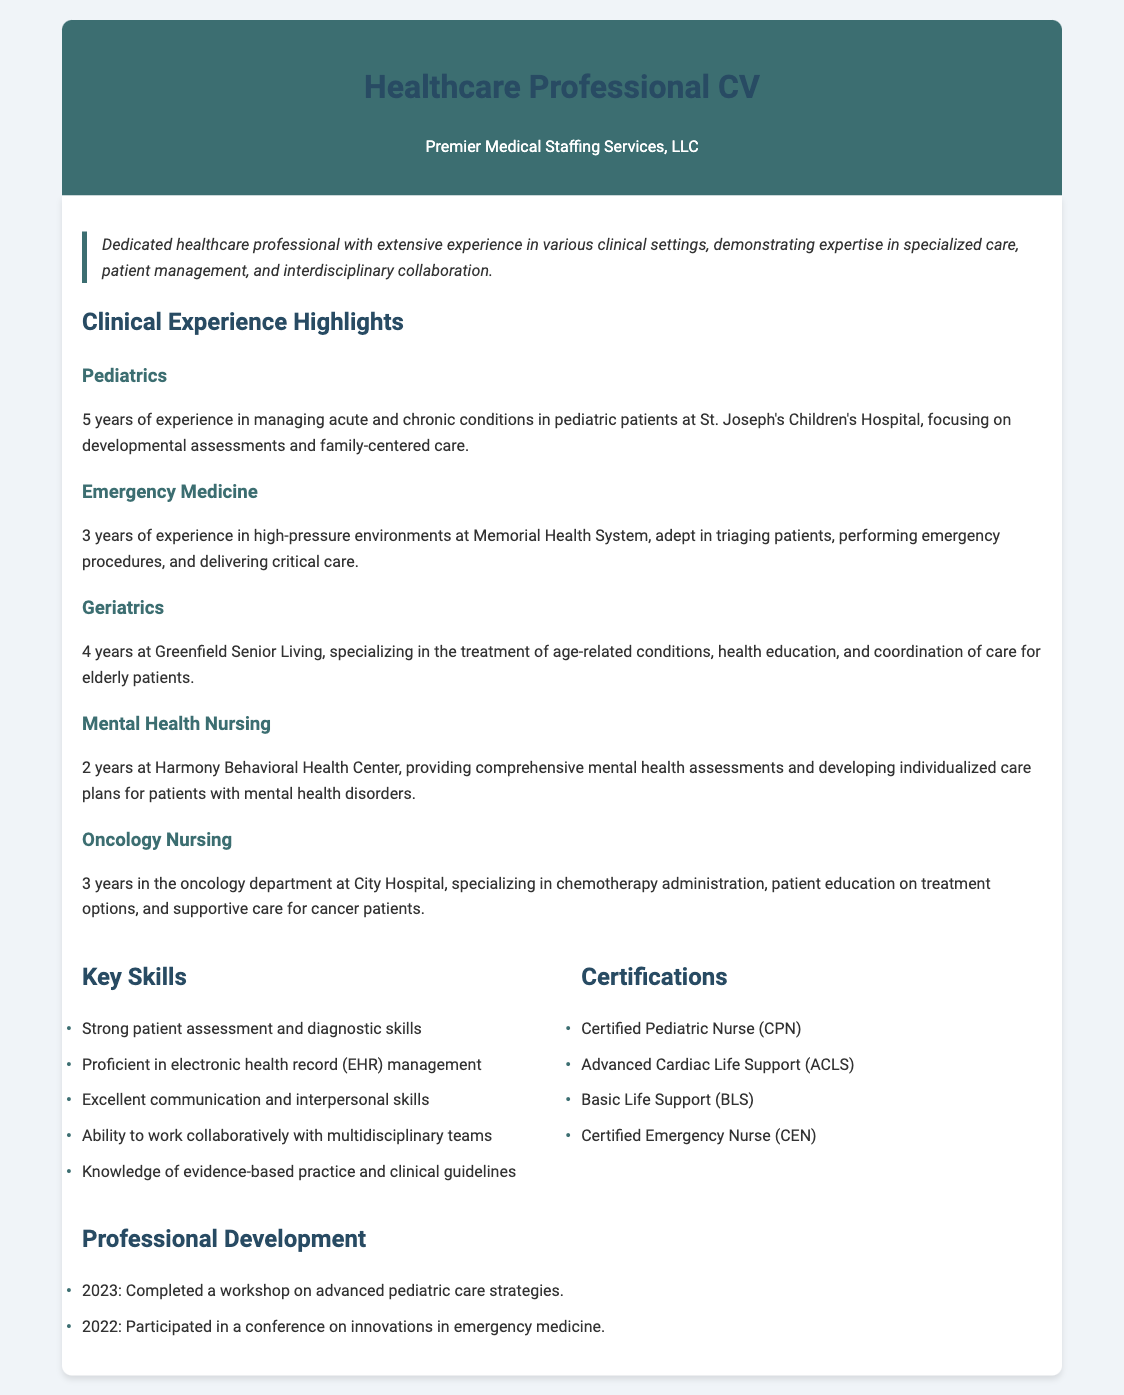What is the total years of experience in Pediatrics? The total years of experience in Pediatrics is 5 years, as stated in the document.
Answer: 5 years Where did the professional work in Emergency Medicine? The professional worked in Emergency Medicine at Memorial Health System, which is mentioned in the document.
Answer: Memorial Health System How many years of experience does the professional have in Geriatrics? The professional has 4 years of experience in Geriatrics, as specified in the corresponding section.
Answer: 4 years What certification is specifically for Pediatric Nursing? The certification specifically for Pediatric Nursing mentioned in the document is Certified Pediatric Nurse (CPN).
Answer: Certified Pediatric Nurse (CPN) What key skill involves teamwork? The key skill that involves teamwork is "Ability to work collaboratively with multidisciplinary teams," as listed under Key Skills.
Answer: Ability to work collaboratively with multidisciplinary teams How many years of experience does the professional have in Mental Health Nursing? The document states that the professional has 2 years of experience in Mental Health Nursing.
Answer: 2 years What was the workshop completed in 2023 about? The workshop completed in 2023 was about advanced pediatric care strategies, based on the Professional Development section.
Answer: Advanced pediatric care strategies In which department did the professional specialize for Oncology Nursing? The professional specialized in the oncology department, as noted in the Oncology Nursing description.
Answer: Oncology department What year did the professional participate in a conference on innovations in emergency medicine? The professional participated in the conference in 2022, as detailed in the Professional Development section.
Answer: 2022 